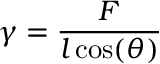<formula> <loc_0><loc_0><loc_500><loc_500>\gamma = { \frac { F } { l \cos ( \theta ) } }</formula> 